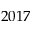Convert formula to latex. <formula><loc_0><loc_0><loc_500><loc_500>2 0 1 7</formula> 